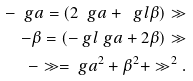<formula> <loc_0><loc_0><loc_500><loc_500>- \ g a = ( 2 \ g a + \ g l \beta ) \gg \\ - \beta = ( - \ g l \ g a + 2 \beta ) \gg \\ - \gg = \ g a ^ { 2 } + \beta ^ { 2 } + \gg ^ { 2 } .</formula> 